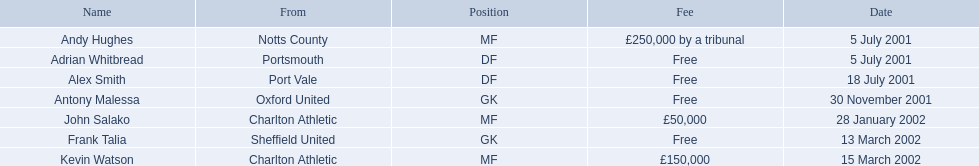Which players in the 2001-02 reading f.c. season played the mf position? Andy Hughes, John Salako, Kevin Watson. Of these players, which ones transferred in 2002? John Salako, Kevin Watson. Of these players, who had the highest transfer fee? Kevin Watson. What was this player's transfer fee? £150,000. 